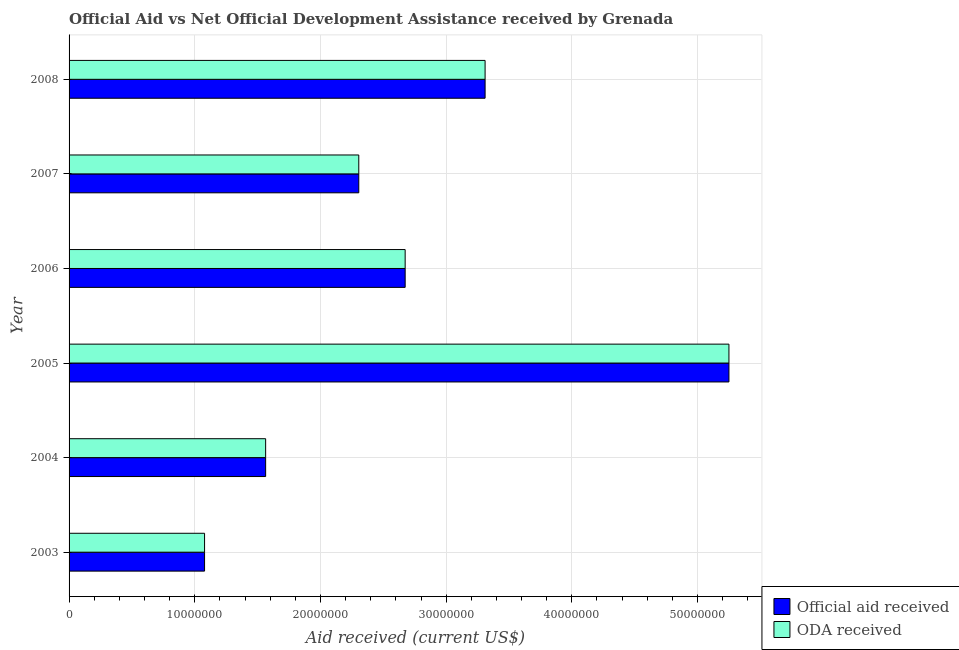How many different coloured bars are there?
Provide a short and direct response. 2. Are the number of bars per tick equal to the number of legend labels?
Ensure brevity in your answer.  Yes. Are the number of bars on each tick of the Y-axis equal?
Make the answer very short. Yes. How many bars are there on the 5th tick from the top?
Offer a very short reply. 2. In how many cases, is the number of bars for a given year not equal to the number of legend labels?
Keep it short and to the point. 0. What is the oda received in 2003?
Make the answer very short. 1.08e+07. Across all years, what is the maximum oda received?
Provide a succinct answer. 5.25e+07. Across all years, what is the minimum oda received?
Offer a terse response. 1.08e+07. In which year was the official aid received minimum?
Your answer should be compact. 2003. What is the total official aid received in the graph?
Your answer should be very brief. 1.62e+08. What is the difference between the official aid received in 2005 and that in 2008?
Your answer should be very brief. 1.94e+07. What is the difference between the official aid received in 2008 and the oda received in 2007?
Provide a short and direct response. 1.00e+07. What is the average official aid received per year?
Make the answer very short. 2.70e+07. In the year 2006, what is the difference between the official aid received and oda received?
Keep it short and to the point. 0. In how many years, is the official aid received greater than 52000000 US$?
Make the answer very short. 1. What is the ratio of the official aid received in 2004 to that in 2007?
Make the answer very short. 0.68. Is the oda received in 2004 less than that in 2006?
Your answer should be compact. Yes. Is the difference between the official aid received in 2004 and 2005 greater than the difference between the oda received in 2004 and 2005?
Give a very brief answer. No. What is the difference between the highest and the second highest oda received?
Keep it short and to the point. 1.94e+07. What is the difference between the highest and the lowest oda received?
Make the answer very short. 4.17e+07. What does the 2nd bar from the top in 2004 represents?
Provide a succinct answer. Official aid received. What does the 2nd bar from the bottom in 2003 represents?
Offer a very short reply. ODA received. Are all the bars in the graph horizontal?
Make the answer very short. Yes. How many years are there in the graph?
Make the answer very short. 6. Does the graph contain any zero values?
Ensure brevity in your answer.  No. Where does the legend appear in the graph?
Make the answer very short. Bottom right. How are the legend labels stacked?
Provide a succinct answer. Vertical. What is the title of the graph?
Your response must be concise. Official Aid vs Net Official Development Assistance received by Grenada . What is the label or title of the X-axis?
Make the answer very short. Aid received (current US$). What is the label or title of the Y-axis?
Keep it short and to the point. Year. What is the Aid received (current US$) of Official aid received in 2003?
Keep it short and to the point. 1.08e+07. What is the Aid received (current US$) in ODA received in 2003?
Offer a very short reply. 1.08e+07. What is the Aid received (current US$) in Official aid received in 2004?
Keep it short and to the point. 1.56e+07. What is the Aid received (current US$) in ODA received in 2004?
Keep it short and to the point. 1.56e+07. What is the Aid received (current US$) in Official aid received in 2005?
Offer a very short reply. 5.25e+07. What is the Aid received (current US$) in ODA received in 2005?
Provide a short and direct response. 5.25e+07. What is the Aid received (current US$) of Official aid received in 2006?
Keep it short and to the point. 2.67e+07. What is the Aid received (current US$) in ODA received in 2006?
Ensure brevity in your answer.  2.67e+07. What is the Aid received (current US$) of Official aid received in 2007?
Give a very brief answer. 2.30e+07. What is the Aid received (current US$) of ODA received in 2007?
Offer a very short reply. 2.30e+07. What is the Aid received (current US$) in Official aid received in 2008?
Provide a succinct answer. 3.31e+07. What is the Aid received (current US$) of ODA received in 2008?
Give a very brief answer. 3.31e+07. Across all years, what is the maximum Aid received (current US$) of Official aid received?
Make the answer very short. 5.25e+07. Across all years, what is the maximum Aid received (current US$) in ODA received?
Your response must be concise. 5.25e+07. Across all years, what is the minimum Aid received (current US$) in Official aid received?
Your answer should be compact. 1.08e+07. Across all years, what is the minimum Aid received (current US$) of ODA received?
Your response must be concise. 1.08e+07. What is the total Aid received (current US$) in Official aid received in the graph?
Ensure brevity in your answer.  1.62e+08. What is the total Aid received (current US$) of ODA received in the graph?
Your response must be concise. 1.62e+08. What is the difference between the Aid received (current US$) of Official aid received in 2003 and that in 2004?
Keep it short and to the point. -4.86e+06. What is the difference between the Aid received (current US$) in ODA received in 2003 and that in 2004?
Keep it short and to the point. -4.86e+06. What is the difference between the Aid received (current US$) in Official aid received in 2003 and that in 2005?
Your response must be concise. -4.17e+07. What is the difference between the Aid received (current US$) of ODA received in 2003 and that in 2005?
Provide a succinct answer. -4.17e+07. What is the difference between the Aid received (current US$) in Official aid received in 2003 and that in 2006?
Keep it short and to the point. -1.60e+07. What is the difference between the Aid received (current US$) in ODA received in 2003 and that in 2006?
Ensure brevity in your answer.  -1.60e+07. What is the difference between the Aid received (current US$) of Official aid received in 2003 and that in 2007?
Make the answer very short. -1.23e+07. What is the difference between the Aid received (current US$) of ODA received in 2003 and that in 2007?
Offer a terse response. -1.23e+07. What is the difference between the Aid received (current US$) of Official aid received in 2003 and that in 2008?
Give a very brief answer. -2.23e+07. What is the difference between the Aid received (current US$) in ODA received in 2003 and that in 2008?
Offer a terse response. -2.23e+07. What is the difference between the Aid received (current US$) of Official aid received in 2004 and that in 2005?
Make the answer very short. -3.69e+07. What is the difference between the Aid received (current US$) of ODA received in 2004 and that in 2005?
Your answer should be very brief. -3.69e+07. What is the difference between the Aid received (current US$) of Official aid received in 2004 and that in 2006?
Your answer should be compact. -1.11e+07. What is the difference between the Aid received (current US$) of ODA received in 2004 and that in 2006?
Make the answer very short. -1.11e+07. What is the difference between the Aid received (current US$) in Official aid received in 2004 and that in 2007?
Offer a very short reply. -7.41e+06. What is the difference between the Aid received (current US$) of ODA received in 2004 and that in 2007?
Your answer should be compact. -7.41e+06. What is the difference between the Aid received (current US$) in Official aid received in 2004 and that in 2008?
Offer a terse response. -1.75e+07. What is the difference between the Aid received (current US$) in ODA received in 2004 and that in 2008?
Your answer should be compact. -1.75e+07. What is the difference between the Aid received (current US$) in Official aid received in 2005 and that in 2006?
Provide a succinct answer. 2.58e+07. What is the difference between the Aid received (current US$) in ODA received in 2005 and that in 2006?
Keep it short and to the point. 2.58e+07. What is the difference between the Aid received (current US$) of Official aid received in 2005 and that in 2007?
Your answer should be compact. 2.94e+07. What is the difference between the Aid received (current US$) in ODA received in 2005 and that in 2007?
Your answer should be very brief. 2.94e+07. What is the difference between the Aid received (current US$) of Official aid received in 2005 and that in 2008?
Make the answer very short. 1.94e+07. What is the difference between the Aid received (current US$) in ODA received in 2005 and that in 2008?
Make the answer very short. 1.94e+07. What is the difference between the Aid received (current US$) of Official aid received in 2006 and that in 2007?
Keep it short and to the point. 3.69e+06. What is the difference between the Aid received (current US$) in ODA received in 2006 and that in 2007?
Make the answer very short. 3.69e+06. What is the difference between the Aid received (current US$) of Official aid received in 2006 and that in 2008?
Keep it short and to the point. -6.36e+06. What is the difference between the Aid received (current US$) in ODA received in 2006 and that in 2008?
Keep it short and to the point. -6.36e+06. What is the difference between the Aid received (current US$) of Official aid received in 2007 and that in 2008?
Your answer should be very brief. -1.00e+07. What is the difference between the Aid received (current US$) in ODA received in 2007 and that in 2008?
Your answer should be compact. -1.00e+07. What is the difference between the Aid received (current US$) of Official aid received in 2003 and the Aid received (current US$) of ODA received in 2004?
Offer a very short reply. -4.86e+06. What is the difference between the Aid received (current US$) of Official aid received in 2003 and the Aid received (current US$) of ODA received in 2005?
Your answer should be very brief. -4.17e+07. What is the difference between the Aid received (current US$) in Official aid received in 2003 and the Aid received (current US$) in ODA received in 2006?
Your answer should be compact. -1.60e+07. What is the difference between the Aid received (current US$) in Official aid received in 2003 and the Aid received (current US$) in ODA received in 2007?
Your answer should be very brief. -1.23e+07. What is the difference between the Aid received (current US$) in Official aid received in 2003 and the Aid received (current US$) in ODA received in 2008?
Offer a very short reply. -2.23e+07. What is the difference between the Aid received (current US$) in Official aid received in 2004 and the Aid received (current US$) in ODA received in 2005?
Your answer should be very brief. -3.69e+07. What is the difference between the Aid received (current US$) in Official aid received in 2004 and the Aid received (current US$) in ODA received in 2006?
Give a very brief answer. -1.11e+07. What is the difference between the Aid received (current US$) of Official aid received in 2004 and the Aid received (current US$) of ODA received in 2007?
Keep it short and to the point. -7.41e+06. What is the difference between the Aid received (current US$) in Official aid received in 2004 and the Aid received (current US$) in ODA received in 2008?
Make the answer very short. -1.75e+07. What is the difference between the Aid received (current US$) of Official aid received in 2005 and the Aid received (current US$) of ODA received in 2006?
Your response must be concise. 2.58e+07. What is the difference between the Aid received (current US$) of Official aid received in 2005 and the Aid received (current US$) of ODA received in 2007?
Your answer should be very brief. 2.94e+07. What is the difference between the Aid received (current US$) of Official aid received in 2005 and the Aid received (current US$) of ODA received in 2008?
Offer a terse response. 1.94e+07. What is the difference between the Aid received (current US$) in Official aid received in 2006 and the Aid received (current US$) in ODA received in 2007?
Make the answer very short. 3.69e+06. What is the difference between the Aid received (current US$) of Official aid received in 2006 and the Aid received (current US$) of ODA received in 2008?
Your answer should be compact. -6.36e+06. What is the difference between the Aid received (current US$) in Official aid received in 2007 and the Aid received (current US$) in ODA received in 2008?
Your answer should be very brief. -1.00e+07. What is the average Aid received (current US$) of Official aid received per year?
Provide a succinct answer. 2.70e+07. What is the average Aid received (current US$) in ODA received per year?
Ensure brevity in your answer.  2.70e+07. In the year 2003, what is the difference between the Aid received (current US$) of Official aid received and Aid received (current US$) of ODA received?
Make the answer very short. 0. In the year 2005, what is the difference between the Aid received (current US$) of Official aid received and Aid received (current US$) of ODA received?
Keep it short and to the point. 0. In the year 2006, what is the difference between the Aid received (current US$) of Official aid received and Aid received (current US$) of ODA received?
Give a very brief answer. 0. In the year 2007, what is the difference between the Aid received (current US$) in Official aid received and Aid received (current US$) in ODA received?
Your answer should be very brief. 0. In the year 2008, what is the difference between the Aid received (current US$) of Official aid received and Aid received (current US$) of ODA received?
Offer a very short reply. 0. What is the ratio of the Aid received (current US$) in Official aid received in 2003 to that in 2004?
Your answer should be compact. 0.69. What is the ratio of the Aid received (current US$) of ODA received in 2003 to that in 2004?
Offer a terse response. 0.69. What is the ratio of the Aid received (current US$) of Official aid received in 2003 to that in 2005?
Offer a very short reply. 0.21. What is the ratio of the Aid received (current US$) of ODA received in 2003 to that in 2005?
Make the answer very short. 0.21. What is the ratio of the Aid received (current US$) in Official aid received in 2003 to that in 2006?
Offer a very short reply. 0.4. What is the ratio of the Aid received (current US$) of ODA received in 2003 to that in 2006?
Your answer should be very brief. 0.4. What is the ratio of the Aid received (current US$) of Official aid received in 2003 to that in 2007?
Your answer should be very brief. 0.47. What is the ratio of the Aid received (current US$) in ODA received in 2003 to that in 2007?
Your answer should be very brief. 0.47. What is the ratio of the Aid received (current US$) in Official aid received in 2003 to that in 2008?
Provide a succinct answer. 0.33. What is the ratio of the Aid received (current US$) of ODA received in 2003 to that in 2008?
Ensure brevity in your answer.  0.33. What is the ratio of the Aid received (current US$) of Official aid received in 2004 to that in 2005?
Your answer should be compact. 0.3. What is the ratio of the Aid received (current US$) of ODA received in 2004 to that in 2005?
Give a very brief answer. 0.3. What is the ratio of the Aid received (current US$) in Official aid received in 2004 to that in 2006?
Your response must be concise. 0.58. What is the ratio of the Aid received (current US$) in ODA received in 2004 to that in 2006?
Give a very brief answer. 0.58. What is the ratio of the Aid received (current US$) of Official aid received in 2004 to that in 2007?
Your answer should be compact. 0.68. What is the ratio of the Aid received (current US$) of ODA received in 2004 to that in 2007?
Give a very brief answer. 0.68. What is the ratio of the Aid received (current US$) in Official aid received in 2004 to that in 2008?
Offer a terse response. 0.47. What is the ratio of the Aid received (current US$) in ODA received in 2004 to that in 2008?
Make the answer very short. 0.47. What is the ratio of the Aid received (current US$) of Official aid received in 2005 to that in 2006?
Your response must be concise. 1.96. What is the ratio of the Aid received (current US$) of ODA received in 2005 to that in 2006?
Offer a very short reply. 1.96. What is the ratio of the Aid received (current US$) of Official aid received in 2005 to that in 2007?
Your answer should be very brief. 2.28. What is the ratio of the Aid received (current US$) in ODA received in 2005 to that in 2007?
Your response must be concise. 2.28. What is the ratio of the Aid received (current US$) of Official aid received in 2005 to that in 2008?
Ensure brevity in your answer.  1.59. What is the ratio of the Aid received (current US$) in ODA received in 2005 to that in 2008?
Your answer should be very brief. 1.59. What is the ratio of the Aid received (current US$) in Official aid received in 2006 to that in 2007?
Make the answer very short. 1.16. What is the ratio of the Aid received (current US$) of ODA received in 2006 to that in 2007?
Offer a very short reply. 1.16. What is the ratio of the Aid received (current US$) of Official aid received in 2006 to that in 2008?
Make the answer very short. 0.81. What is the ratio of the Aid received (current US$) in ODA received in 2006 to that in 2008?
Give a very brief answer. 0.81. What is the ratio of the Aid received (current US$) of Official aid received in 2007 to that in 2008?
Keep it short and to the point. 0.7. What is the ratio of the Aid received (current US$) in ODA received in 2007 to that in 2008?
Ensure brevity in your answer.  0.7. What is the difference between the highest and the second highest Aid received (current US$) of Official aid received?
Your answer should be compact. 1.94e+07. What is the difference between the highest and the second highest Aid received (current US$) in ODA received?
Ensure brevity in your answer.  1.94e+07. What is the difference between the highest and the lowest Aid received (current US$) in Official aid received?
Provide a short and direct response. 4.17e+07. What is the difference between the highest and the lowest Aid received (current US$) of ODA received?
Your answer should be very brief. 4.17e+07. 